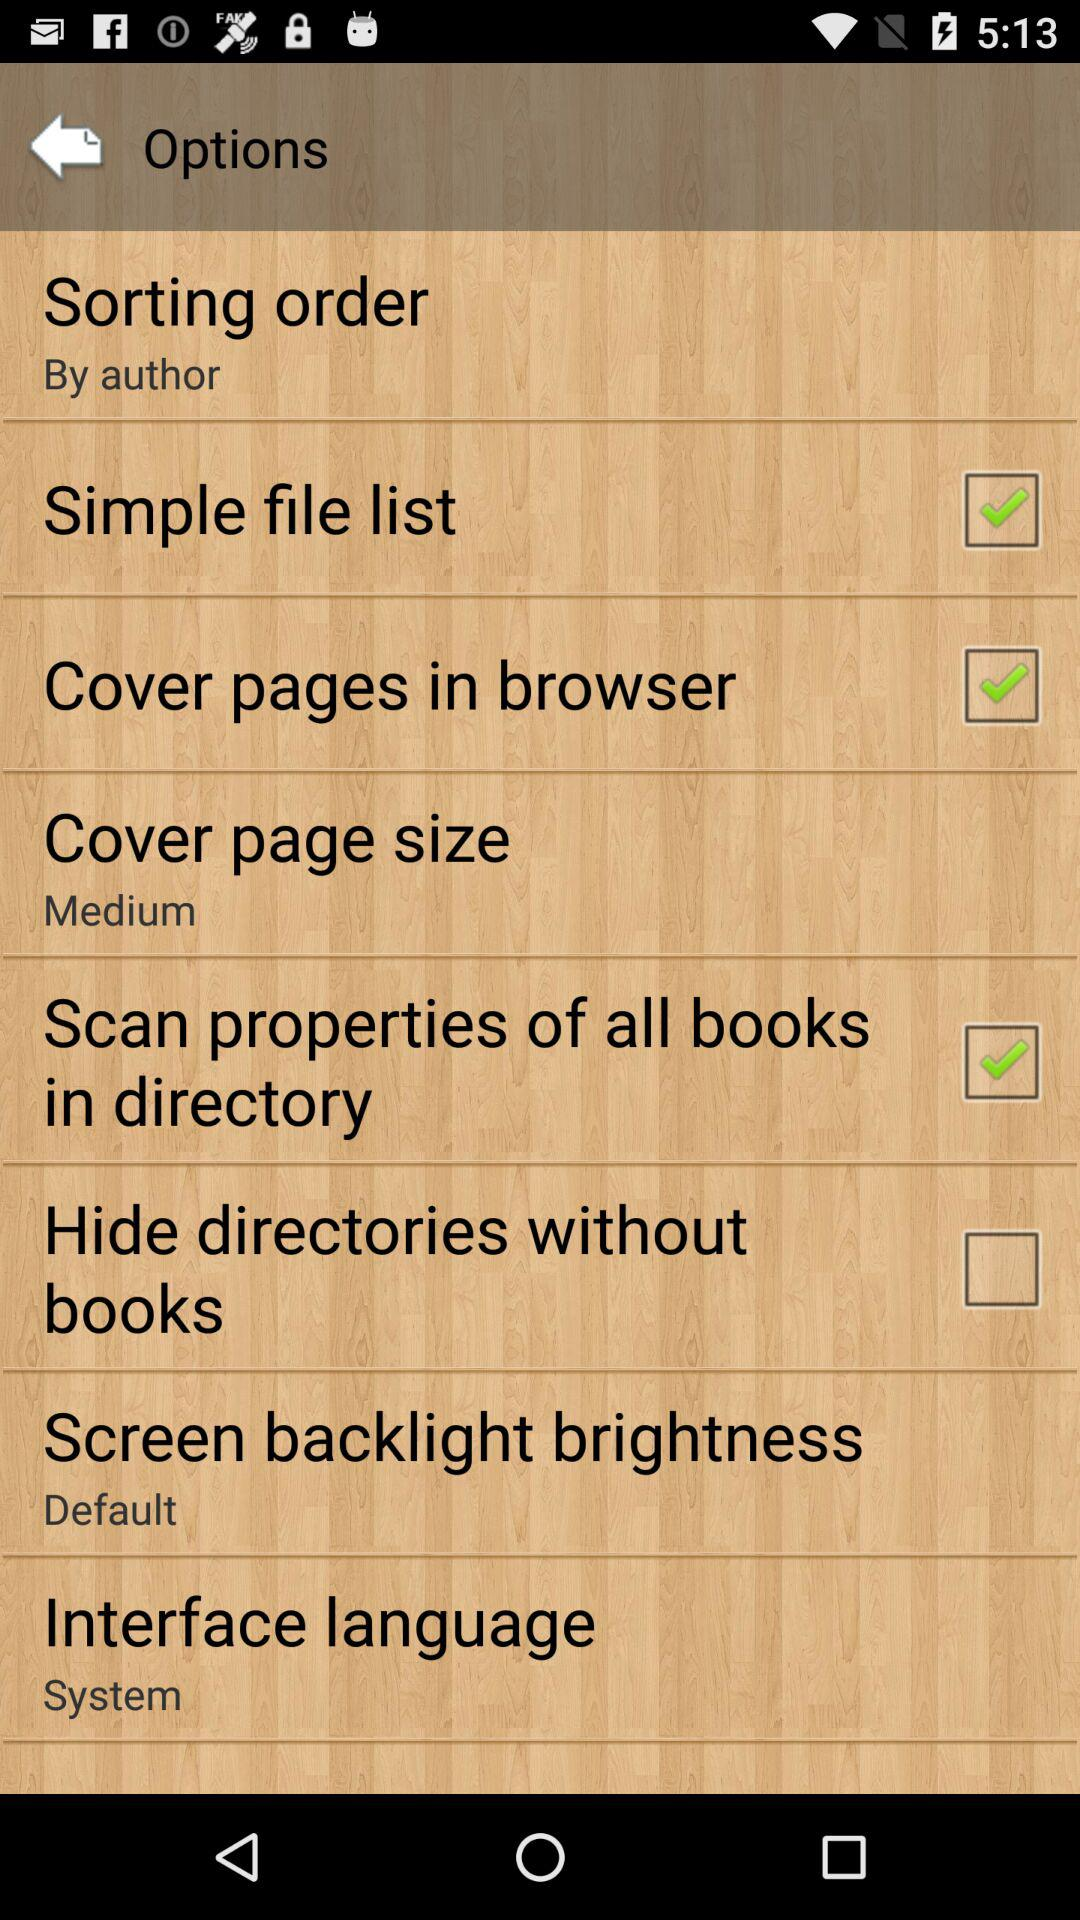What is the setting for the cover page size? The setting for the cover page size is "Medium". 